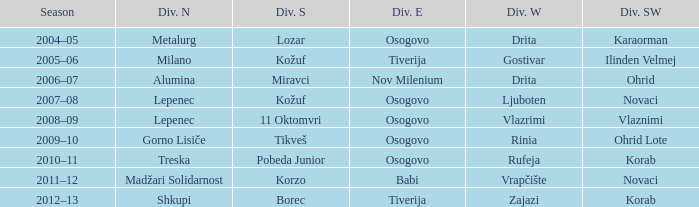Who won Division Southwest when Madžari Solidarnost won Division North? Novaci. 